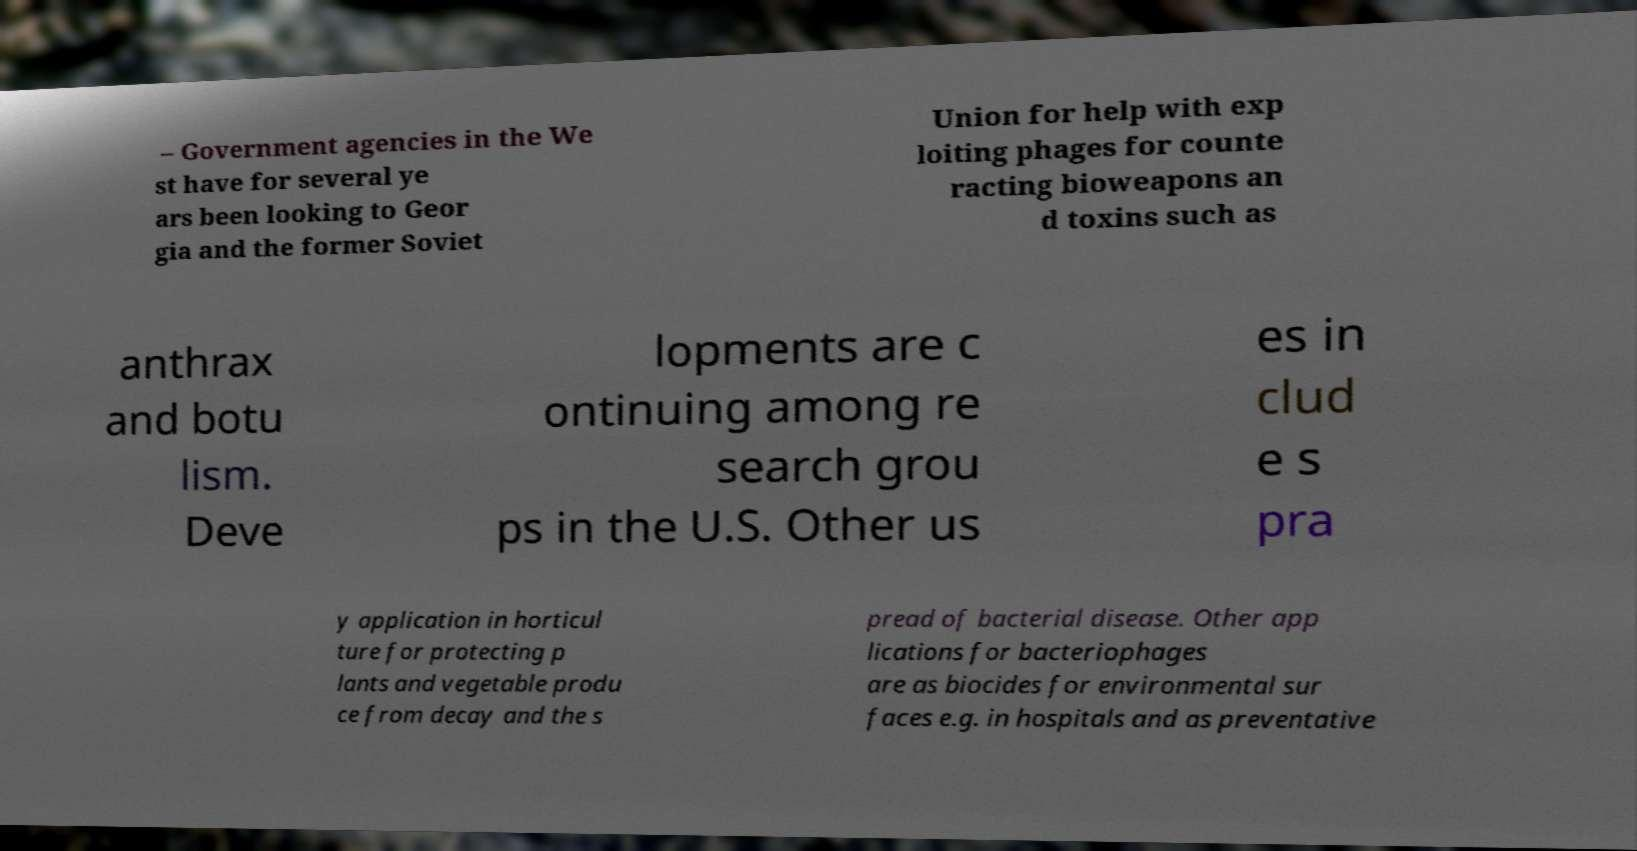Please read and relay the text visible in this image. What does it say? – Government agencies in the We st have for several ye ars been looking to Geor gia and the former Soviet Union for help with exp loiting phages for counte racting bioweapons an d toxins such as anthrax and botu lism. Deve lopments are c ontinuing among re search grou ps in the U.S. Other us es in clud e s pra y application in horticul ture for protecting p lants and vegetable produ ce from decay and the s pread of bacterial disease. Other app lications for bacteriophages are as biocides for environmental sur faces e.g. in hospitals and as preventative 